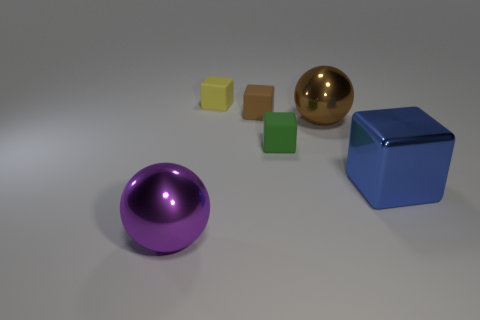Subtract all tiny yellow matte cubes. How many cubes are left? 3 Subtract all brown spheres. How many spheres are left? 1 Subtract all spheres. How many objects are left? 4 Add 1 green rubber things. How many objects exist? 7 Subtract all red balls. How many blue cubes are left? 1 Add 2 green things. How many green things exist? 3 Subtract 1 green cubes. How many objects are left? 5 Subtract 2 balls. How many balls are left? 0 Subtract all cyan balls. Subtract all brown blocks. How many balls are left? 2 Subtract all metallic objects. Subtract all brown rubber cubes. How many objects are left? 2 